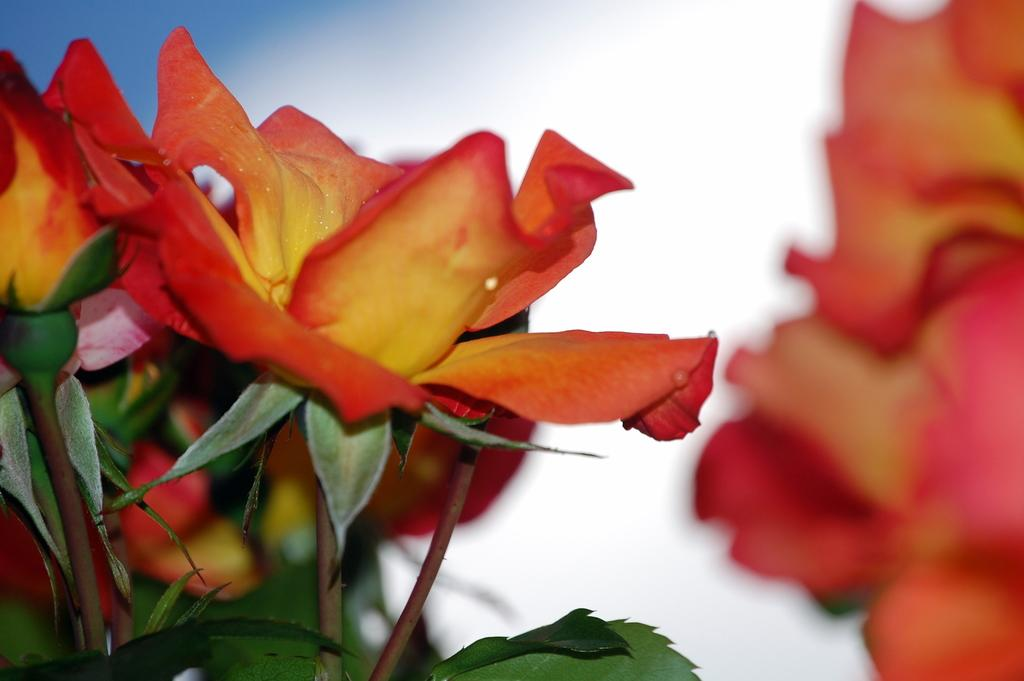What type of plants can be seen in the picture? There are flowers in the picture. What parts of the flowers are visible? The flowers have leaves and stems. Can you describe the color of one of the flowers in the picture? There is an orange color flower at the right side of the picture, but it is blurred. What type of transportation can be seen at the airport in the picture? There is no airport or transportation present in the picture; it features flowers with leaves and stems. What emotion is the flower feeling in the picture? Flowers do not have emotions, so it is not possible to determine what emotion the flower might be feeling. 